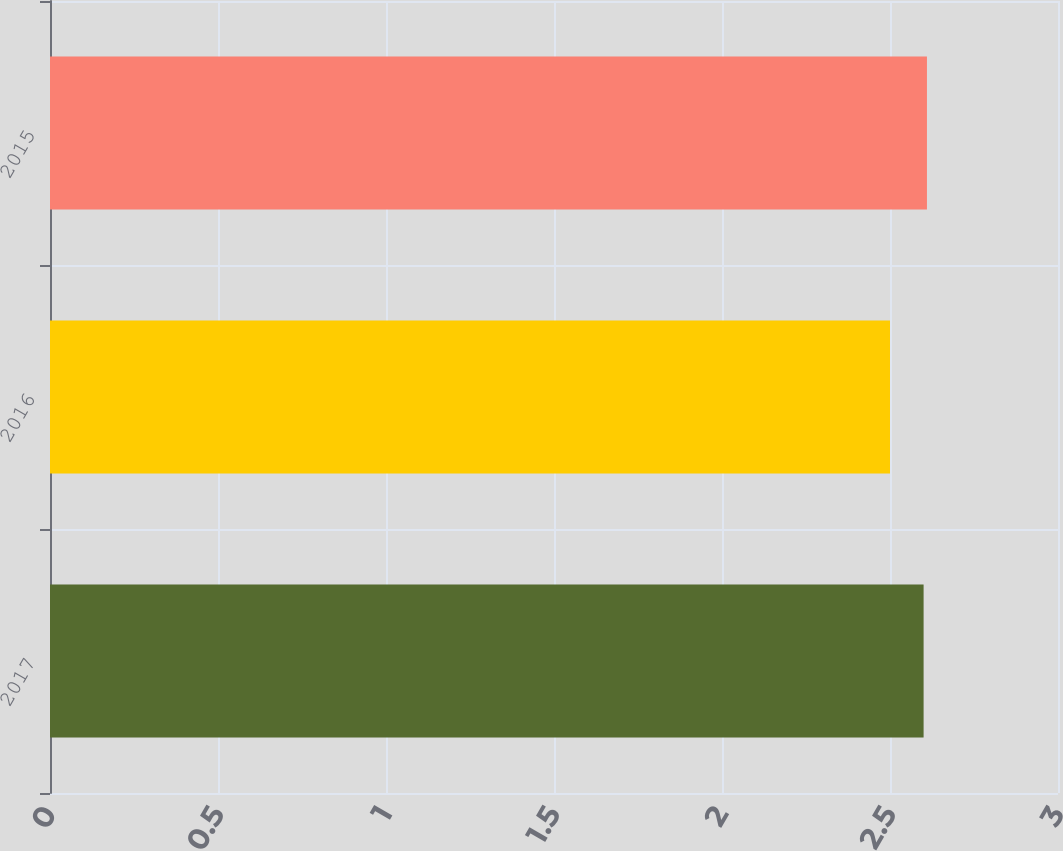<chart> <loc_0><loc_0><loc_500><loc_500><bar_chart><fcel>2017<fcel>2016<fcel>2015<nl><fcel>2.6<fcel>2.5<fcel>2.61<nl></chart> 